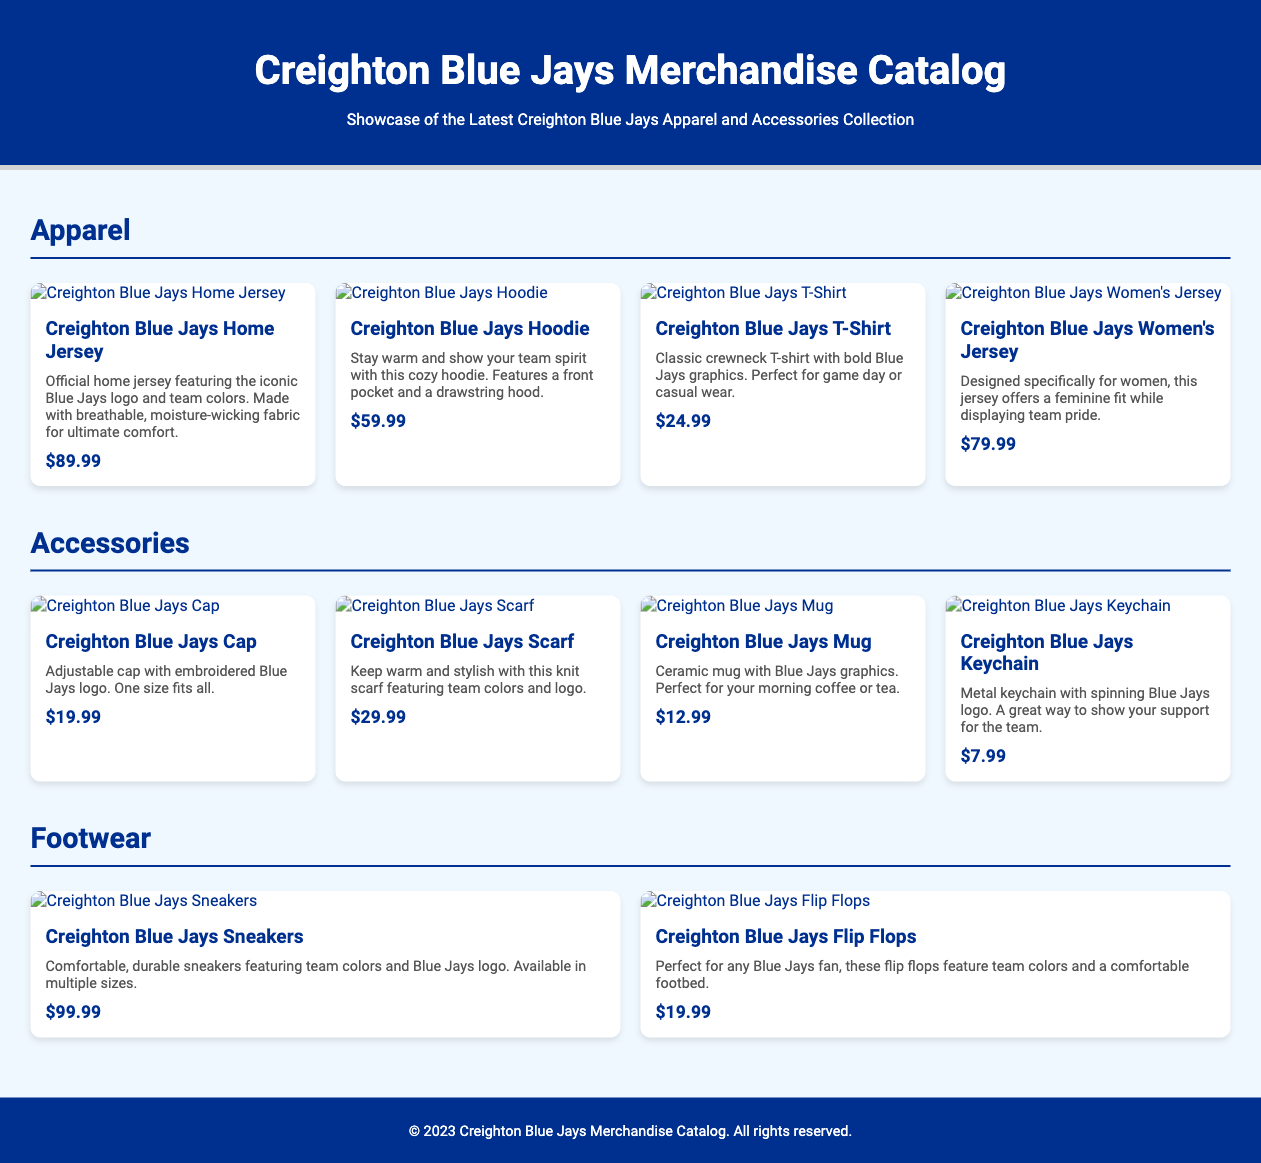what is the price of the Creighton Blue Jays Home Jersey? The price listed in the document for the Creighton Blue Jays Home Jersey is $89.99.
Answer: $89.99 how many different types of apparel are featured in the catalog? The document lists four types of apparel: Home Jersey, Hoodie, T-Shirt, and Women's Jersey.
Answer: Four what is the main color associated with the Creighton Blue Jays? The predominant color seen throughout the document, representing the team, is blue, specifically #00308F.
Answer: Blue which accessory has the lowest price? The lowest priced accessory in the document is the Creighton Blue Jays Keychain at $7.99.
Answer: $7.99 what features does the Creighton Blue Jays Hoodie have? The document describes the hoodie as cozy with a front pocket and a drawstring hood.
Answer: Front pocket and drawstring hood how many footwear items are mentioned in the merchandise catalog? The document features two footwear items: Sneakers and Flip Flops.
Answer: Two what type of product is the Creighton Blue Jays Scarf? The scarf is categorized as an accessory in the merchandise catalog.
Answer: Accessory what is the price range of the apparel items? The apparel prices range from $24.99 for the T-Shirt to $89.99 for the Home Jersey.
Answer: $24.99 - $89.99 what type of product is the Creighton Blue Jays Mug? According to the document, the mug is classified as an accessory.
Answer: Accessory 